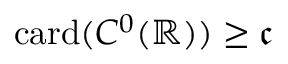<formula> <loc_0><loc_0><loc_500><loc_500>c a r d ( C ^ { 0 } ( \mathbb { R } ) ) \geq { \mathfrak { c } }</formula> 